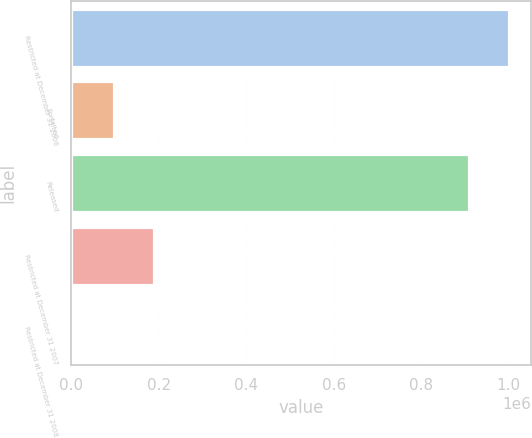<chart> <loc_0><loc_0><loc_500><loc_500><bar_chart><fcel>Restricted at December 31 2006<fcel>Forfeited<fcel>Released<fcel>Restricted at December 31 2007<fcel>Restricted at December 31 2008<nl><fcel>1.00092e+06<fcel>97395.5<fcel>908217<fcel>190101<fcel>4690<nl></chart> 